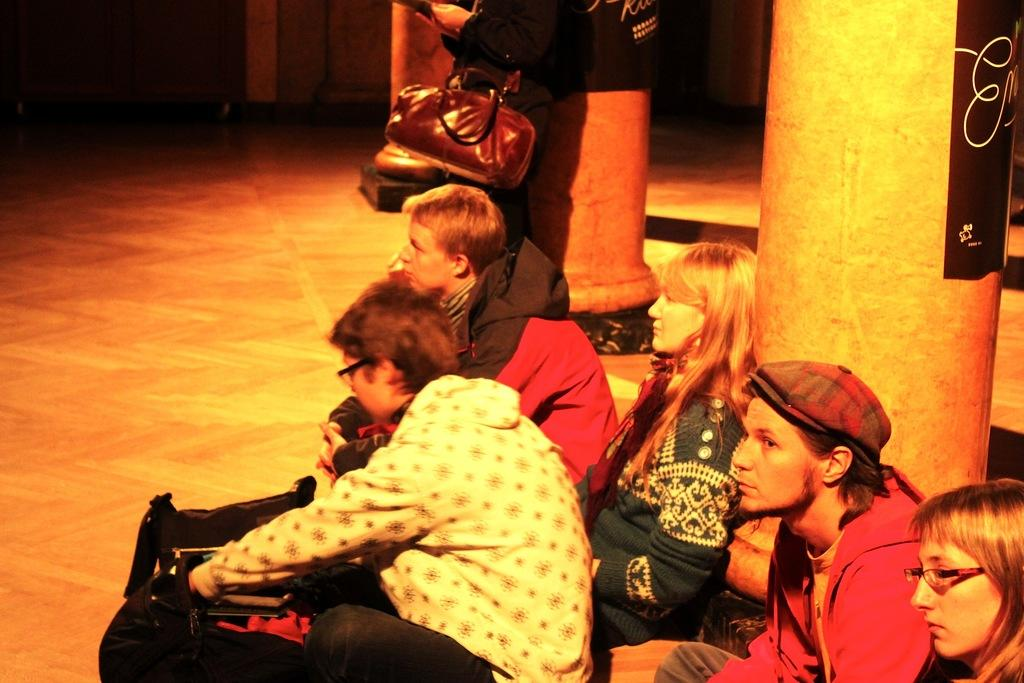What are the people in the image doing? The people in the image are on the floor. What can be seen in the background of the image? There are pillars and some objects visible in the background of the image. What is the price of the quartz displayed on the floor in the image? There is no quartz present in the image, so it is not possible to determine its price. 